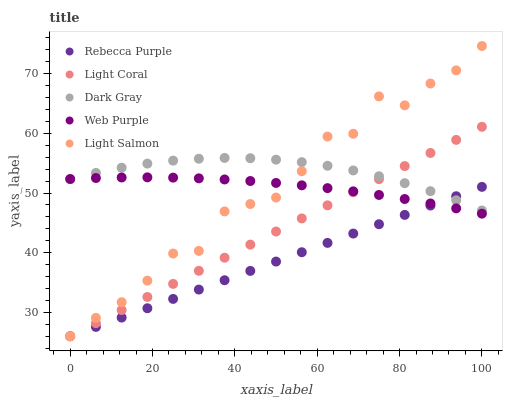Does Rebecca Purple have the minimum area under the curve?
Answer yes or no. Yes. Does Dark Gray have the maximum area under the curve?
Answer yes or no. Yes. Does Web Purple have the minimum area under the curve?
Answer yes or no. No. Does Web Purple have the maximum area under the curve?
Answer yes or no. No. Is Light Coral the smoothest?
Answer yes or no. Yes. Is Light Salmon the roughest?
Answer yes or no. Yes. Is Dark Gray the smoothest?
Answer yes or no. No. Is Dark Gray the roughest?
Answer yes or no. No. Does Light Coral have the lowest value?
Answer yes or no. Yes. Does Web Purple have the lowest value?
Answer yes or no. No. Does Light Salmon have the highest value?
Answer yes or no. Yes. Does Dark Gray have the highest value?
Answer yes or no. No. Does Dark Gray intersect Light Coral?
Answer yes or no. Yes. Is Dark Gray less than Light Coral?
Answer yes or no. No. Is Dark Gray greater than Light Coral?
Answer yes or no. No. 